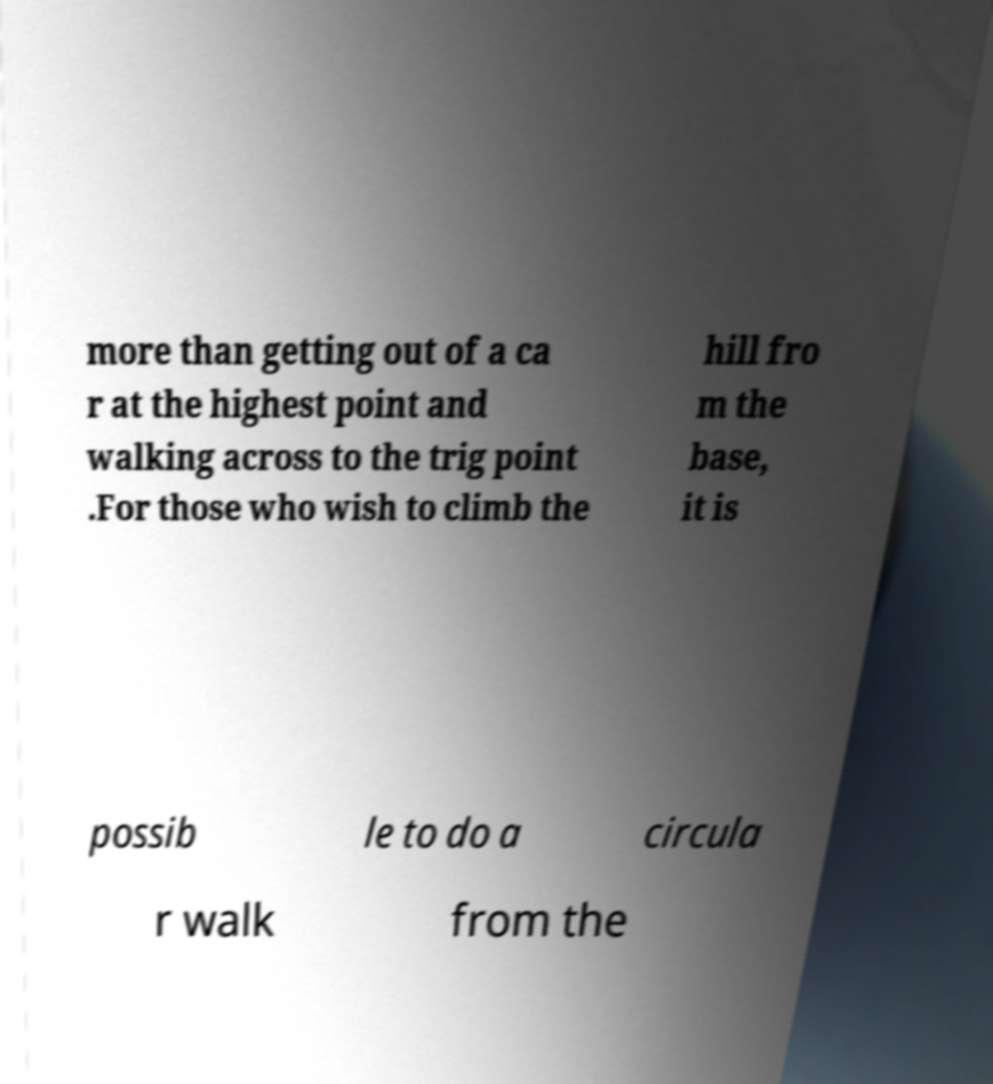I need the written content from this picture converted into text. Can you do that? more than getting out of a ca r at the highest point and walking across to the trig point .For those who wish to climb the hill fro m the base, it is possib le to do a circula r walk from the 